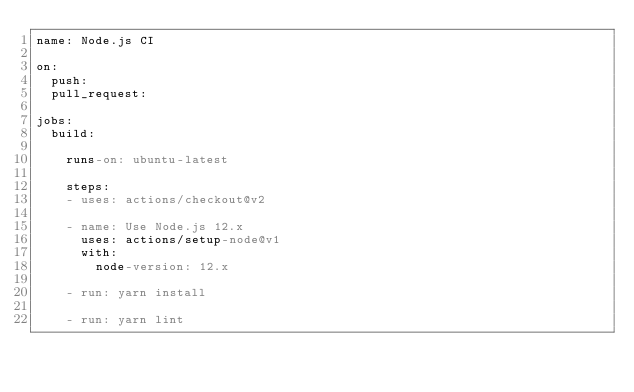Convert code to text. <code><loc_0><loc_0><loc_500><loc_500><_YAML_>name: Node.js CI

on:
  push:
  pull_request:

jobs:
  build:

    runs-on: ubuntu-latest

    steps:
    - uses: actions/checkout@v2

    - name: Use Node.js 12.x
      uses: actions/setup-node@v1
      with:
        node-version: 12.x

    - run: yarn install

    - run: yarn lint
</code> 